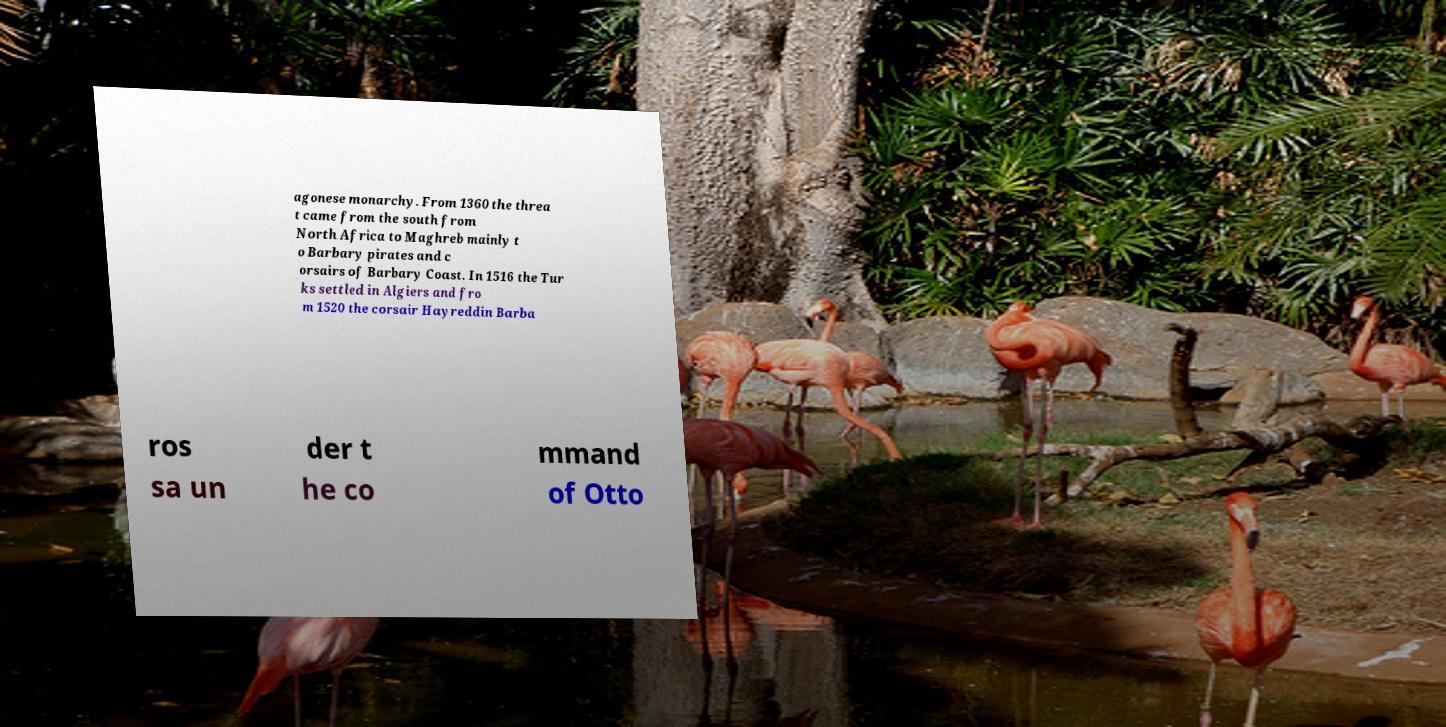Please identify and transcribe the text found in this image. agonese monarchy. From 1360 the threa t came from the south from North Africa to Maghreb mainly t o Barbary pirates and c orsairs of Barbary Coast. In 1516 the Tur ks settled in Algiers and fro m 1520 the corsair Hayreddin Barba ros sa un der t he co mmand of Otto 